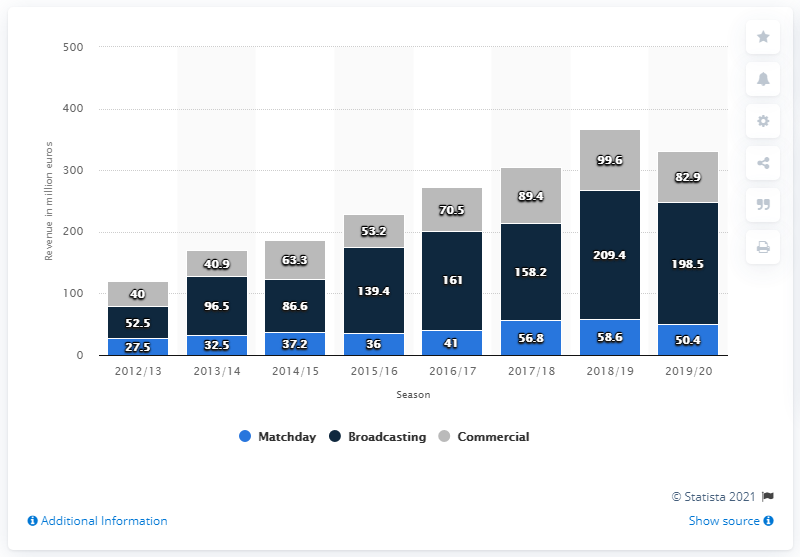Indicate a few pertinent items in this graphic. The total revenue collected for broadcasting in 2018 was 209.4 million. In the year 2013, the difference between match day and 2012 was 5. Atlético de Madrid earned 198.5 million euros from broadcasting revenues in the 2019/2020 season. The amount of commercial sponsorship and merchandising earned in 2019/2020 was 82.9 million dollars. 